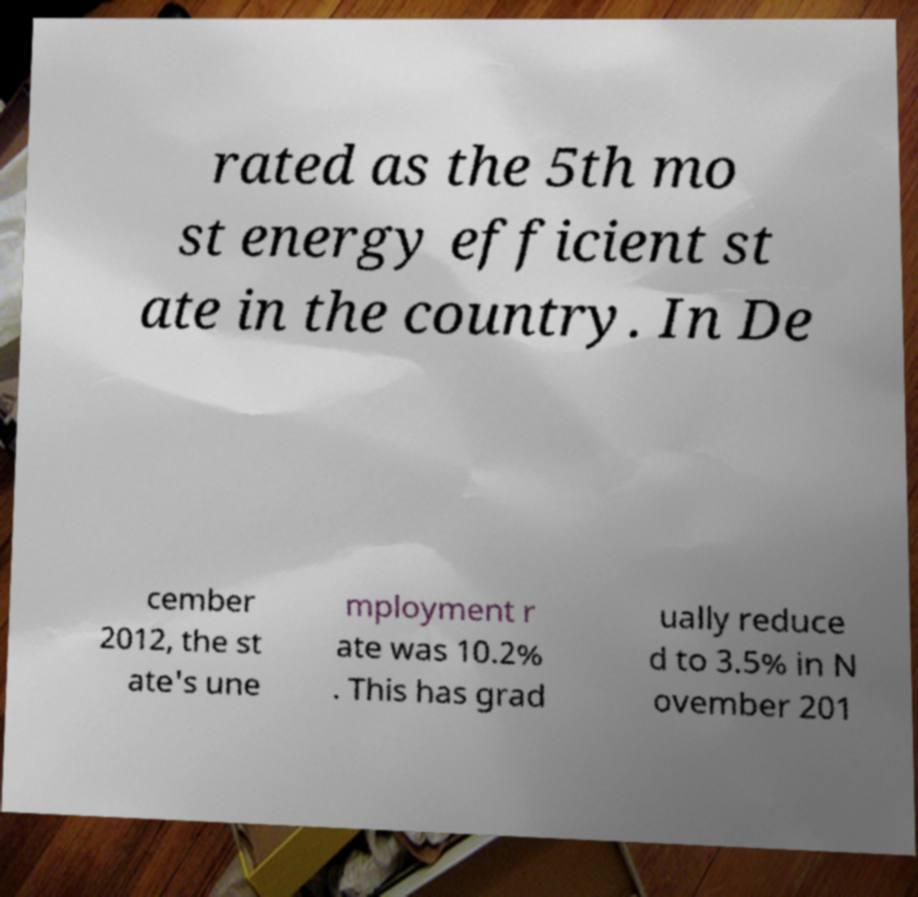Could you assist in decoding the text presented in this image and type it out clearly? rated as the 5th mo st energy efficient st ate in the country. In De cember 2012, the st ate's une mployment r ate was 10.2% . This has grad ually reduce d to 3.5% in N ovember 201 